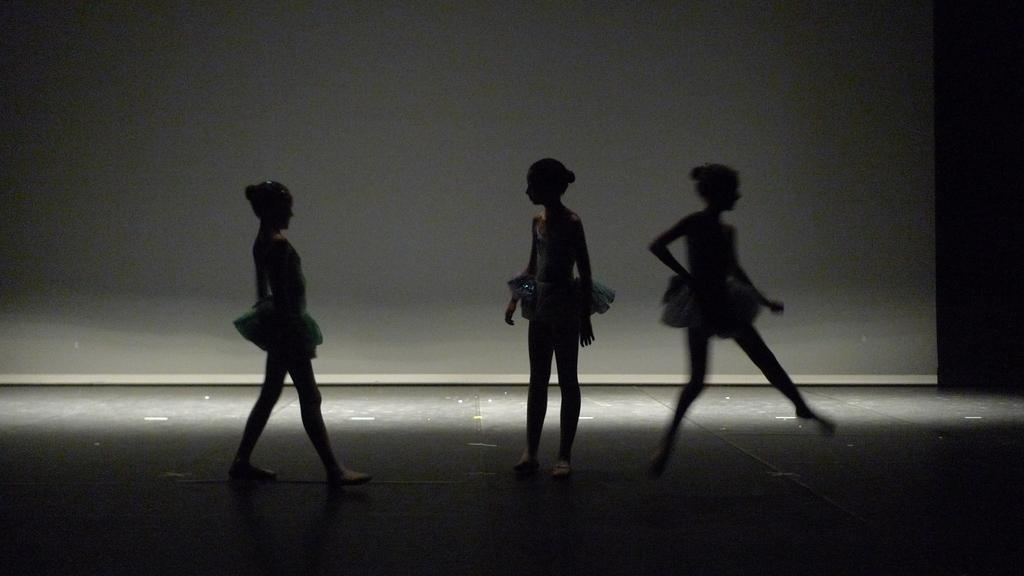What can be seen in the image? There are persons standing in the image. What is present in the background of the image? There is a board in the background of the image. What is the color of the board? The board is white in color. What type of government is depicted on the board in the image? There is no indication of any government or political content on the board in the image; it is simply a white board. 